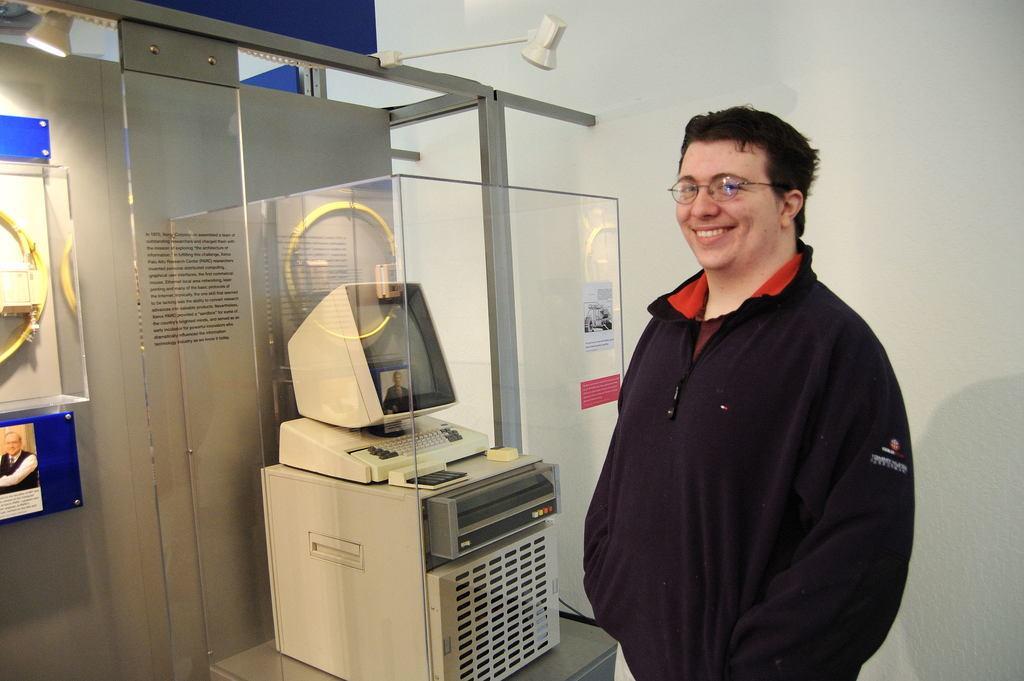In one or two sentences, can you explain what this image depicts? In this picture I can see a man standing he wore spectacles and I can see a monitor, keyboard in the glass box and I can see another glass box on the left side of the picture and I can see a small poster with some text and a picture of a man. 